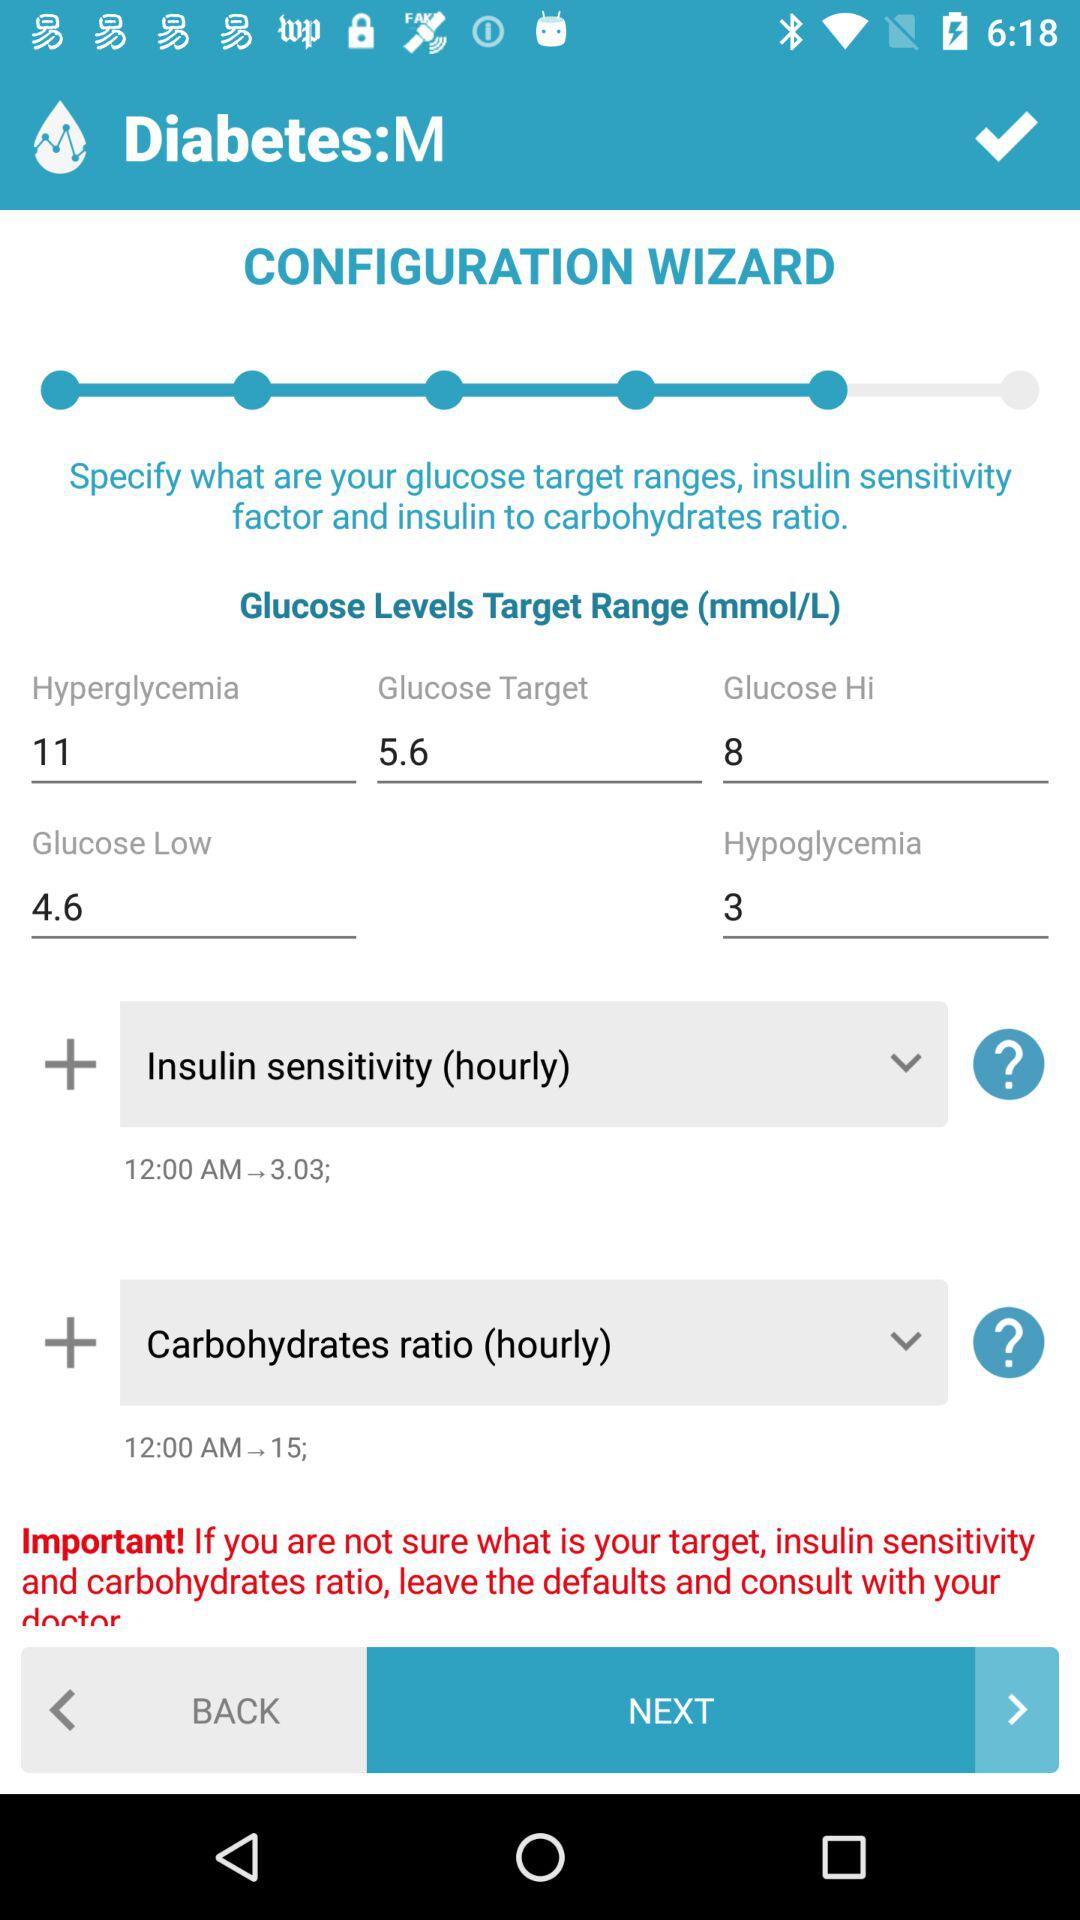What is the name of the application? The application name is "Diabetes:M". 